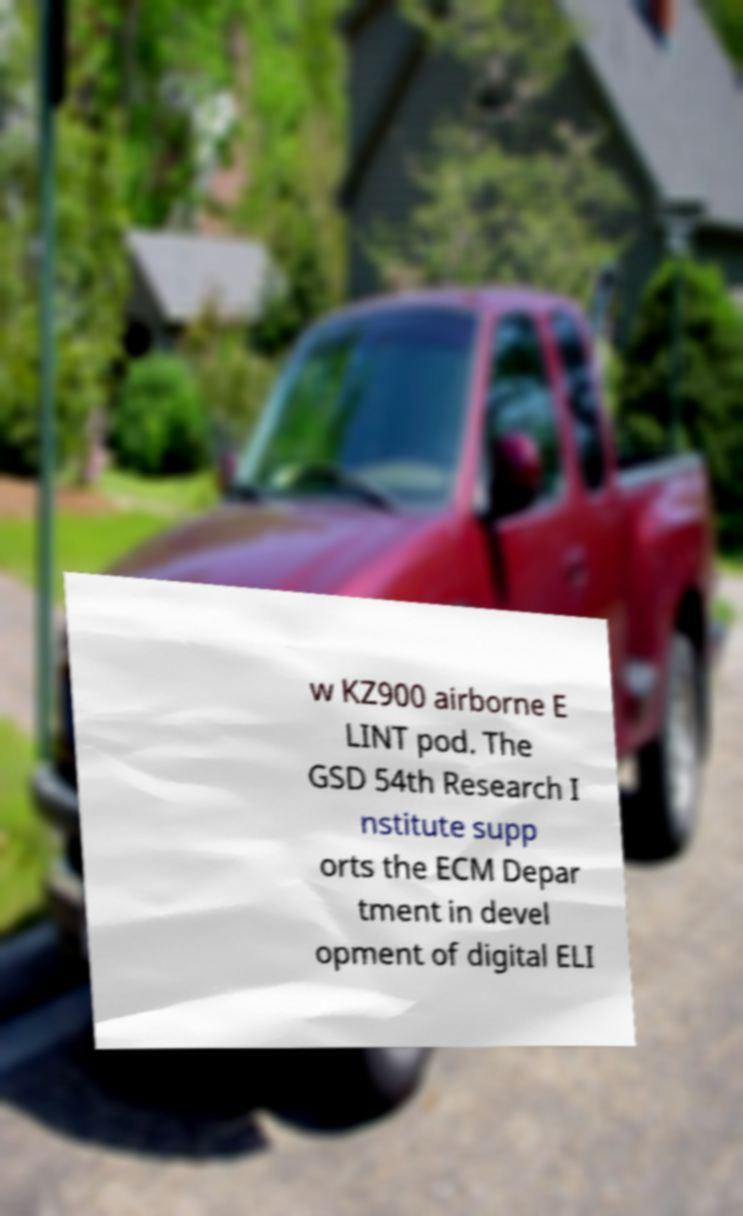What messages or text are displayed in this image? I need them in a readable, typed format. w KZ900 airborne E LINT pod. The GSD 54th Research I nstitute supp orts the ECM Depar tment in devel opment of digital ELI 